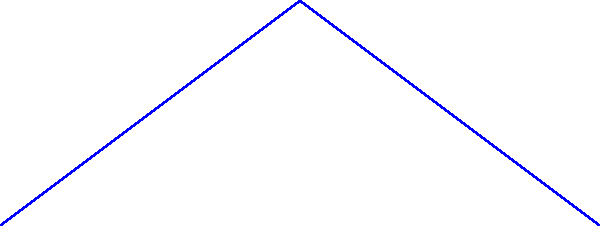Consider two flight paths from point A to point C on a flat map projection: a great circle route (red arc) and a rhumb line (blue straight line). Which path appears to have greater curvature on this projection, and why is this representation potentially misleading for actual flight distances? To answer this question, let's break it down step-by-step:

1. Curvature on the projection:
   - The great circle route (red arc) appears to have greater curvature on this flat map projection.
   - The rhumb line (blue straight line) appears as a straight line with no curvature.

2. Representation vs. reality:
   - Great circle routes are actually the shortest distance between two points on a sphere (like the Earth).
   - Rhumb lines maintain a constant bearing but are usually longer than great circle routes.

3. Why the representation is misleading:
   - Flat map projections distort the Earth's spherical surface.
   - Great circles, which are straight lines on a globe, appear curved on flat projections.
   - Rhumb lines, which are curved on a globe, appear straight on certain flat projections (e.g., Mercator).

4. Impact on flight distances:
   - The straight rhumb line might appear shorter on this projection.
   - In reality, the curved great circle route is typically the shorter path for long-distance flights.

5. Navigational implications:
   - Pilots often use a combination of great circle and rhumb line navigation.
   - Great circles for overall route planning, rhumb lines for easier navigation between waypoints.

This representation is misleading because it doesn't accurately reflect the true shortest distance on the Earth's surface, potentially leading to misconceptions about optimal flight paths.
Answer: Great circle route; flat projections distort spherical distances. 